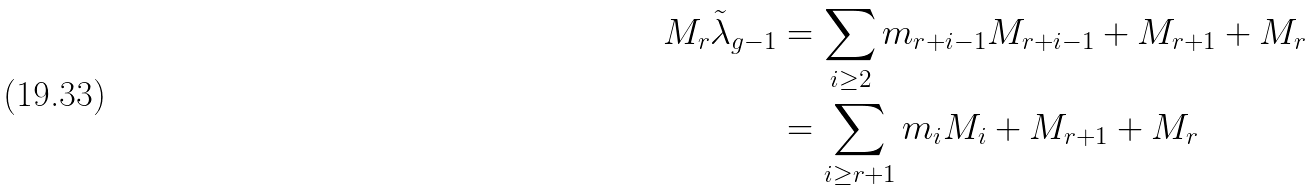<formula> <loc_0><loc_0><loc_500><loc_500>M _ { r } \tilde { \lambda } _ { g - 1 } & = \sum _ { i \geq 2 } m _ { r + i - 1 } M _ { r + i - 1 } + M _ { r + 1 } + M _ { r } \\ & = \sum _ { i \geq r + 1 } m _ { i } M _ { i } + M _ { r + 1 } + M _ { r }</formula> 